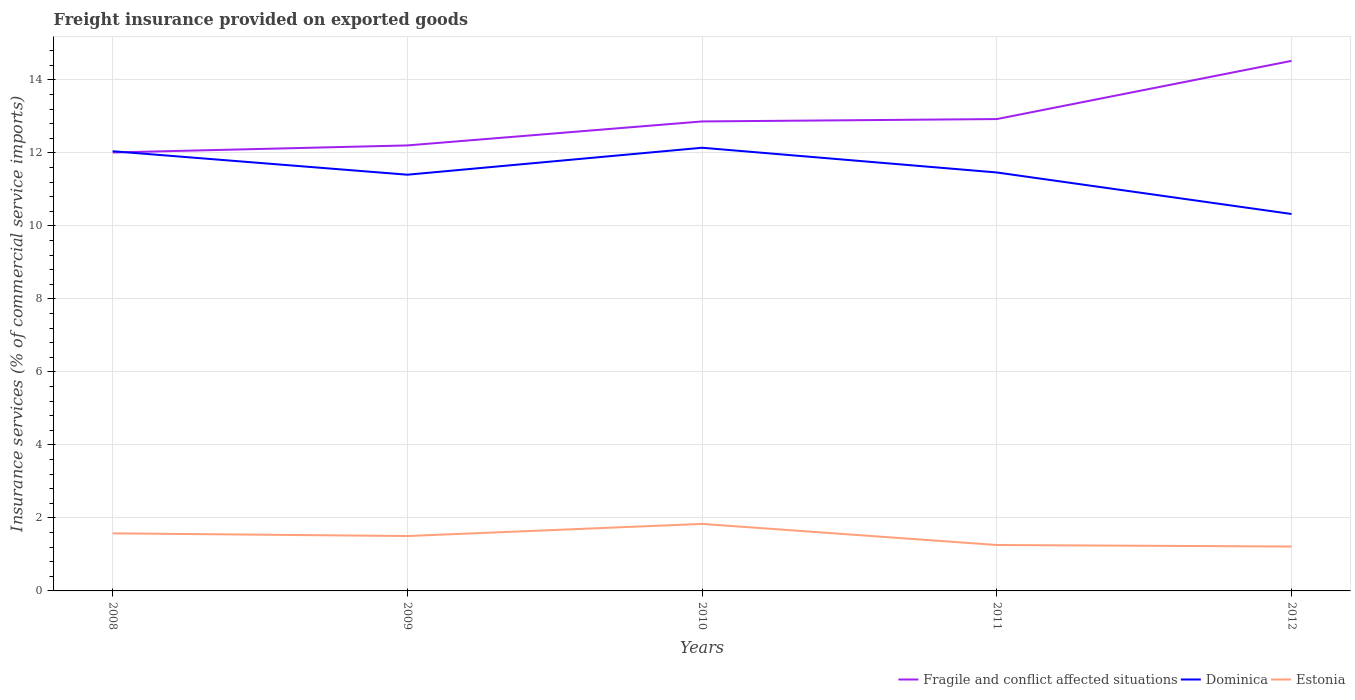Across all years, what is the maximum freight insurance provided on exported goods in Estonia?
Provide a short and direct response. 1.22. What is the total freight insurance provided on exported goods in Fragile and conflict affected situations in the graph?
Ensure brevity in your answer.  -2.32. What is the difference between the highest and the second highest freight insurance provided on exported goods in Fragile and conflict affected situations?
Offer a terse response. 2.51. Is the freight insurance provided on exported goods in Fragile and conflict affected situations strictly greater than the freight insurance provided on exported goods in Estonia over the years?
Your answer should be very brief. No. How many lines are there?
Offer a terse response. 3. What is the difference between two consecutive major ticks on the Y-axis?
Make the answer very short. 2. Are the values on the major ticks of Y-axis written in scientific E-notation?
Your response must be concise. No. Where does the legend appear in the graph?
Ensure brevity in your answer.  Bottom right. How many legend labels are there?
Provide a succinct answer. 3. What is the title of the graph?
Keep it short and to the point. Freight insurance provided on exported goods. Does "Sao Tome and Principe" appear as one of the legend labels in the graph?
Provide a succinct answer. No. What is the label or title of the X-axis?
Give a very brief answer. Years. What is the label or title of the Y-axis?
Your response must be concise. Insurance services (% of commercial service imports). What is the Insurance services (% of commercial service imports) in Fragile and conflict affected situations in 2008?
Provide a short and direct response. 12.01. What is the Insurance services (% of commercial service imports) in Dominica in 2008?
Your answer should be very brief. 12.05. What is the Insurance services (% of commercial service imports) of Estonia in 2008?
Make the answer very short. 1.58. What is the Insurance services (% of commercial service imports) of Fragile and conflict affected situations in 2009?
Ensure brevity in your answer.  12.21. What is the Insurance services (% of commercial service imports) in Dominica in 2009?
Make the answer very short. 11.4. What is the Insurance services (% of commercial service imports) of Estonia in 2009?
Offer a very short reply. 1.5. What is the Insurance services (% of commercial service imports) in Fragile and conflict affected situations in 2010?
Provide a succinct answer. 12.86. What is the Insurance services (% of commercial service imports) of Dominica in 2010?
Your response must be concise. 12.14. What is the Insurance services (% of commercial service imports) in Estonia in 2010?
Your answer should be very brief. 1.84. What is the Insurance services (% of commercial service imports) of Fragile and conflict affected situations in 2011?
Your answer should be compact. 12.93. What is the Insurance services (% of commercial service imports) in Dominica in 2011?
Make the answer very short. 11.46. What is the Insurance services (% of commercial service imports) of Estonia in 2011?
Your response must be concise. 1.26. What is the Insurance services (% of commercial service imports) in Fragile and conflict affected situations in 2012?
Provide a succinct answer. 14.52. What is the Insurance services (% of commercial service imports) in Dominica in 2012?
Your answer should be compact. 10.33. What is the Insurance services (% of commercial service imports) of Estonia in 2012?
Keep it short and to the point. 1.22. Across all years, what is the maximum Insurance services (% of commercial service imports) of Fragile and conflict affected situations?
Your answer should be compact. 14.52. Across all years, what is the maximum Insurance services (% of commercial service imports) of Dominica?
Ensure brevity in your answer.  12.14. Across all years, what is the maximum Insurance services (% of commercial service imports) of Estonia?
Offer a terse response. 1.84. Across all years, what is the minimum Insurance services (% of commercial service imports) of Fragile and conflict affected situations?
Your answer should be compact. 12.01. Across all years, what is the minimum Insurance services (% of commercial service imports) of Dominica?
Ensure brevity in your answer.  10.33. Across all years, what is the minimum Insurance services (% of commercial service imports) in Estonia?
Offer a very short reply. 1.22. What is the total Insurance services (% of commercial service imports) of Fragile and conflict affected situations in the graph?
Provide a succinct answer. 64.53. What is the total Insurance services (% of commercial service imports) of Dominica in the graph?
Keep it short and to the point. 57.38. What is the total Insurance services (% of commercial service imports) in Estonia in the graph?
Offer a terse response. 7.39. What is the difference between the Insurance services (% of commercial service imports) in Fragile and conflict affected situations in 2008 and that in 2009?
Make the answer very short. -0.19. What is the difference between the Insurance services (% of commercial service imports) in Dominica in 2008 and that in 2009?
Your answer should be very brief. 0.64. What is the difference between the Insurance services (% of commercial service imports) in Estonia in 2008 and that in 2009?
Make the answer very short. 0.07. What is the difference between the Insurance services (% of commercial service imports) of Fragile and conflict affected situations in 2008 and that in 2010?
Give a very brief answer. -0.85. What is the difference between the Insurance services (% of commercial service imports) in Dominica in 2008 and that in 2010?
Your response must be concise. -0.1. What is the difference between the Insurance services (% of commercial service imports) of Estonia in 2008 and that in 2010?
Provide a succinct answer. -0.26. What is the difference between the Insurance services (% of commercial service imports) of Fragile and conflict affected situations in 2008 and that in 2011?
Keep it short and to the point. -0.92. What is the difference between the Insurance services (% of commercial service imports) in Dominica in 2008 and that in 2011?
Your response must be concise. 0.58. What is the difference between the Insurance services (% of commercial service imports) of Estonia in 2008 and that in 2011?
Offer a very short reply. 0.32. What is the difference between the Insurance services (% of commercial service imports) of Fragile and conflict affected situations in 2008 and that in 2012?
Provide a succinct answer. -2.51. What is the difference between the Insurance services (% of commercial service imports) in Dominica in 2008 and that in 2012?
Provide a succinct answer. 1.72. What is the difference between the Insurance services (% of commercial service imports) in Estonia in 2008 and that in 2012?
Provide a succinct answer. 0.36. What is the difference between the Insurance services (% of commercial service imports) of Fragile and conflict affected situations in 2009 and that in 2010?
Your answer should be compact. -0.66. What is the difference between the Insurance services (% of commercial service imports) in Dominica in 2009 and that in 2010?
Your answer should be very brief. -0.74. What is the difference between the Insurance services (% of commercial service imports) in Estonia in 2009 and that in 2010?
Give a very brief answer. -0.33. What is the difference between the Insurance services (% of commercial service imports) of Fragile and conflict affected situations in 2009 and that in 2011?
Your answer should be very brief. -0.72. What is the difference between the Insurance services (% of commercial service imports) in Dominica in 2009 and that in 2011?
Your answer should be very brief. -0.06. What is the difference between the Insurance services (% of commercial service imports) in Estonia in 2009 and that in 2011?
Make the answer very short. 0.25. What is the difference between the Insurance services (% of commercial service imports) of Fragile and conflict affected situations in 2009 and that in 2012?
Make the answer very short. -2.32. What is the difference between the Insurance services (% of commercial service imports) of Dominica in 2009 and that in 2012?
Your answer should be compact. 1.08. What is the difference between the Insurance services (% of commercial service imports) in Estonia in 2009 and that in 2012?
Give a very brief answer. 0.29. What is the difference between the Insurance services (% of commercial service imports) of Fragile and conflict affected situations in 2010 and that in 2011?
Ensure brevity in your answer.  -0.06. What is the difference between the Insurance services (% of commercial service imports) in Dominica in 2010 and that in 2011?
Offer a terse response. 0.68. What is the difference between the Insurance services (% of commercial service imports) in Estonia in 2010 and that in 2011?
Your response must be concise. 0.58. What is the difference between the Insurance services (% of commercial service imports) of Fragile and conflict affected situations in 2010 and that in 2012?
Make the answer very short. -1.66. What is the difference between the Insurance services (% of commercial service imports) of Dominica in 2010 and that in 2012?
Make the answer very short. 1.82. What is the difference between the Insurance services (% of commercial service imports) of Estonia in 2010 and that in 2012?
Make the answer very short. 0.62. What is the difference between the Insurance services (% of commercial service imports) of Fragile and conflict affected situations in 2011 and that in 2012?
Make the answer very short. -1.59. What is the difference between the Insurance services (% of commercial service imports) of Dominica in 2011 and that in 2012?
Offer a terse response. 1.14. What is the difference between the Insurance services (% of commercial service imports) of Estonia in 2011 and that in 2012?
Keep it short and to the point. 0.04. What is the difference between the Insurance services (% of commercial service imports) in Fragile and conflict affected situations in 2008 and the Insurance services (% of commercial service imports) in Dominica in 2009?
Your answer should be compact. 0.61. What is the difference between the Insurance services (% of commercial service imports) of Fragile and conflict affected situations in 2008 and the Insurance services (% of commercial service imports) of Estonia in 2009?
Provide a short and direct response. 10.51. What is the difference between the Insurance services (% of commercial service imports) in Dominica in 2008 and the Insurance services (% of commercial service imports) in Estonia in 2009?
Provide a succinct answer. 10.54. What is the difference between the Insurance services (% of commercial service imports) in Fragile and conflict affected situations in 2008 and the Insurance services (% of commercial service imports) in Dominica in 2010?
Provide a short and direct response. -0.13. What is the difference between the Insurance services (% of commercial service imports) in Fragile and conflict affected situations in 2008 and the Insurance services (% of commercial service imports) in Estonia in 2010?
Your response must be concise. 10.18. What is the difference between the Insurance services (% of commercial service imports) in Dominica in 2008 and the Insurance services (% of commercial service imports) in Estonia in 2010?
Your answer should be very brief. 10.21. What is the difference between the Insurance services (% of commercial service imports) in Fragile and conflict affected situations in 2008 and the Insurance services (% of commercial service imports) in Dominica in 2011?
Your answer should be very brief. 0.55. What is the difference between the Insurance services (% of commercial service imports) in Fragile and conflict affected situations in 2008 and the Insurance services (% of commercial service imports) in Estonia in 2011?
Your answer should be compact. 10.75. What is the difference between the Insurance services (% of commercial service imports) of Dominica in 2008 and the Insurance services (% of commercial service imports) of Estonia in 2011?
Give a very brief answer. 10.79. What is the difference between the Insurance services (% of commercial service imports) in Fragile and conflict affected situations in 2008 and the Insurance services (% of commercial service imports) in Dominica in 2012?
Your response must be concise. 1.69. What is the difference between the Insurance services (% of commercial service imports) of Fragile and conflict affected situations in 2008 and the Insurance services (% of commercial service imports) of Estonia in 2012?
Ensure brevity in your answer.  10.8. What is the difference between the Insurance services (% of commercial service imports) of Dominica in 2008 and the Insurance services (% of commercial service imports) of Estonia in 2012?
Offer a very short reply. 10.83. What is the difference between the Insurance services (% of commercial service imports) of Fragile and conflict affected situations in 2009 and the Insurance services (% of commercial service imports) of Dominica in 2010?
Your response must be concise. 0.06. What is the difference between the Insurance services (% of commercial service imports) of Fragile and conflict affected situations in 2009 and the Insurance services (% of commercial service imports) of Estonia in 2010?
Offer a terse response. 10.37. What is the difference between the Insurance services (% of commercial service imports) of Dominica in 2009 and the Insurance services (% of commercial service imports) of Estonia in 2010?
Give a very brief answer. 9.57. What is the difference between the Insurance services (% of commercial service imports) in Fragile and conflict affected situations in 2009 and the Insurance services (% of commercial service imports) in Dominica in 2011?
Offer a very short reply. 0.74. What is the difference between the Insurance services (% of commercial service imports) of Fragile and conflict affected situations in 2009 and the Insurance services (% of commercial service imports) of Estonia in 2011?
Offer a very short reply. 10.95. What is the difference between the Insurance services (% of commercial service imports) of Dominica in 2009 and the Insurance services (% of commercial service imports) of Estonia in 2011?
Your answer should be very brief. 10.15. What is the difference between the Insurance services (% of commercial service imports) of Fragile and conflict affected situations in 2009 and the Insurance services (% of commercial service imports) of Dominica in 2012?
Your answer should be compact. 1.88. What is the difference between the Insurance services (% of commercial service imports) in Fragile and conflict affected situations in 2009 and the Insurance services (% of commercial service imports) in Estonia in 2012?
Offer a very short reply. 10.99. What is the difference between the Insurance services (% of commercial service imports) in Dominica in 2009 and the Insurance services (% of commercial service imports) in Estonia in 2012?
Offer a very short reply. 10.19. What is the difference between the Insurance services (% of commercial service imports) in Fragile and conflict affected situations in 2010 and the Insurance services (% of commercial service imports) in Dominica in 2011?
Your answer should be compact. 1.4. What is the difference between the Insurance services (% of commercial service imports) in Fragile and conflict affected situations in 2010 and the Insurance services (% of commercial service imports) in Estonia in 2011?
Give a very brief answer. 11.6. What is the difference between the Insurance services (% of commercial service imports) of Dominica in 2010 and the Insurance services (% of commercial service imports) of Estonia in 2011?
Your response must be concise. 10.88. What is the difference between the Insurance services (% of commercial service imports) of Fragile and conflict affected situations in 2010 and the Insurance services (% of commercial service imports) of Dominica in 2012?
Your response must be concise. 2.54. What is the difference between the Insurance services (% of commercial service imports) of Fragile and conflict affected situations in 2010 and the Insurance services (% of commercial service imports) of Estonia in 2012?
Your answer should be very brief. 11.65. What is the difference between the Insurance services (% of commercial service imports) in Dominica in 2010 and the Insurance services (% of commercial service imports) in Estonia in 2012?
Your response must be concise. 10.93. What is the difference between the Insurance services (% of commercial service imports) in Fragile and conflict affected situations in 2011 and the Insurance services (% of commercial service imports) in Dominica in 2012?
Offer a very short reply. 2.6. What is the difference between the Insurance services (% of commercial service imports) in Fragile and conflict affected situations in 2011 and the Insurance services (% of commercial service imports) in Estonia in 2012?
Offer a very short reply. 11.71. What is the difference between the Insurance services (% of commercial service imports) in Dominica in 2011 and the Insurance services (% of commercial service imports) in Estonia in 2012?
Keep it short and to the point. 10.25. What is the average Insurance services (% of commercial service imports) of Fragile and conflict affected situations per year?
Make the answer very short. 12.91. What is the average Insurance services (% of commercial service imports) of Dominica per year?
Give a very brief answer. 11.48. What is the average Insurance services (% of commercial service imports) in Estonia per year?
Offer a terse response. 1.48. In the year 2008, what is the difference between the Insurance services (% of commercial service imports) of Fragile and conflict affected situations and Insurance services (% of commercial service imports) of Dominica?
Provide a short and direct response. -0.03. In the year 2008, what is the difference between the Insurance services (% of commercial service imports) of Fragile and conflict affected situations and Insurance services (% of commercial service imports) of Estonia?
Ensure brevity in your answer.  10.43. In the year 2008, what is the difference between the Insurance services (% of commercial service imports) of Dominica and Insurance services (% of commercial service imports) of Estonia?
Make the answer very short. 10.47. In the year 2009, what is the difference between the Insurance services (% of commercial service imports) of Fragile and conflict affected situations and Insurance services (% of commercial service imports) of Dominica?
Make the answer very short. 0.8. In the year 2009, what is the difference between the Insurance services (% of commercial service imports) in Fragile and conflict affected situations and Insurance services (% of commercial service imports) in Estonia?
Provide a succinct answer. 10.7. In the year 2009, what is the difference between the Insurance services (% of commercial service imports) in Dominica and Insurance services (% of commercial service imports) in Estonia?
Ensure brevity in your answer.  9.9. In the year 2010, what is the difference between the Insurance services (% of commercial service imports) of Fragile and conflict affected situations and Insurance services (% of commercial service imports) of Dominica?
Offer a terse response. 0.72. In the year 2010, what is the difference between the Insurance services (% of commercial service imports) in Fragile and conflict affected situations and Insurance services (% of commercial service imports) in Estonia?
Your answer should be compact. 11.03. In the year 2010, what is the difference between the Insurance services (% of commercial service imports) of Dominica and Insurance services (% of commercial service imports) of Estonia?
Your answer should be compact. 10.31. In the year 2011, what is the difference between the Insurance services (% of commercial service imports) of Fragile and conflict affected situations and Insurance services (% of commercial service imports) of Dominica?
Your answer should be very brief. 1.46. In the year 2011, what is the difference between the Insurance services (% of commercial service imports) of Fragile and conflict affected situations and Insurance services (% of commercial service imports) of Estonia?
Keep it short and to the point. 11.67. In the year 2011, what is the difference between the Insurance services (% of commercial service imports) in Dominica and Insurance services (% of commercial service imports) in Estonia?
Make the answer very short. 10.21. In the year 2012, what is the difference between the Insurance services (% of commercial service imports) of Fragile and conflict affected situations and Insurance services (% of commercial service imports) of Dominica?
Ensure brevity in your answer.  4.2. In the year 2012, what is the difference between the Insurance services (% of commercial service imports) of Fragile and conflict affected situations and Insurance services (% of commercial service imports) of Estonia?
Your answer should be compact. 13.31. In the year 2012, what is the difference between the Insurance services (% of commercial service imports) of Dominica and Insurance services (% of commercial service imports) of Estonia?
Ensure brevity in your answer.  9.11. What is the ratio of the Insurance services (% of commercial service imports) of Fragile and conflict affected situations in 2008 to that in 2009?
Offer a terse response. 0.98. What is the ratio of the Insurance services (% of commercial service imports) of Dominica in 2008 to that in 2009?
Make the answer very short. 1.06. What is the ratio of the Insurance services (% of commercial service imports) of Estonia in 2008 to that in 2009?
Provide a succinct answer. 1.05. What is the ratio of the Insurance services (% of commercial service imports) of Fragile and conflict affected situations in 2008 to that in 2010?
Your answer should be compact. 0.93. What is the ratio of the Insurance services (% of commercial service imports) of Estonia in 2008 to that in 2010?
Ensure brevity in your answer.  0.86. What is the ratio of the Insurance services (% of commercial service imports) in Fragile and conflict affected situations in 2008 to that in 2011?
Provide a short and direct response. 0.93. What is the ratio of the Insurance services (% of commercial service imports) in Dominica in 2008 to that in 2011?
Your response must be concise. 1.05. What is the ratio of the Insurance services (% of commercial service imports) of Estonia in 2008 to that in 2011?
Ensure brevity in your answer.  1.25. What is the ratio of the Insurance services (% of commercial service imports) of Fragile and conflict affected situations in 2008 to that in 2012?
Make the answer very short. 0.83. What is the ratio of the Insurance services (% of commercial service imports) of Dominica in 2008 to that in 2012?
Give a very brief answer. 1.17. What is the ratio of the Insurance services (% of commercial service imports) of Estonia in 2008 to that in 2012?
Offer a terse response. 1.3. What is the ratio of the Insurance services (% of commercial service imports) of Fragile and conflict affected situations in 2009 to that in 2010?
Your answer should be very brief. 0.95. What is the ratio of the Insurance services (% of commercial service imports) in Dominica in 2009 to that in 2010?
Ensure brevity in your answer.  0.94. What is the ratio of the Insurance services (% of commercial service imports) in Estonia in 2009 to that in 2010?
Provide a short and direct response. 0.82. What is the ratio of the Insurance services (% of commercial service imports) of Fragile and conflict affected situations in 2009 to that in 2011?
Offer a terse response. 0.94. What is the ratio of the Insurance services (% of commercial service imports) of Dominica in 2009 to that in 2011?
Give a very brief answer. 0.99. What is the ratio of the Insurance services (% of commercial service imports) of Estonia in 2009 to that in 2011?
Your answer should be very brief. 1.2. What is the ratio of the Insurance services (% of commercial service imports) of Fragile and conflict affected situations in 2009 to that in 2012?
Make the answer very short. 0.84. What is the ratio of the Insurance services (% of commercial service imports) in Dominica in 2009 to that in 2012?
Provide a short and direct response. 1.1. What is the ratio of the Insurance services (% of commercial service imports) in Estonia in 2009 to that in 2012?
Offer a very short reply. 1.24. What is the ratio of the Insurance services (% of commercial service imports) in Fragile and conflict affected situations in 2010 to that in 2011?
Your answer should be compact. 0.99. What is the ratio of the Insurance services (% of commercial service imports) in Dominica in 2010 to that in 2011?
Your answer should be very brief. 1.06. What is the ratio of the Insurance services (% of commercial service imports) of Estonia in 2010 to that in 2011?
Make the answer very short. 1.46. What is the ratio of the Insurance services (% of commercial service imports) in Fragile and conflict affected situations in 2010 to that in 2012?
Offer a very short reply. 0.89. What is the ratio of the Insurance services (% of commercial service imports) in Dominica in 2010 to that in 2012?
Your response must be concise. 1.18. What is the ratio of the Insurance services (% of commercial service imports) in Estonia in 2010 to that in 2012?
Provide a succinct answer. 1.51. What is the ratio of the Insurance services (% of commercial service imports) of Fragile and conflict affected situations in 2011 to that in 2012?
Offer a very short reply. 0.89. What is the ratio of the Insurance services (% of commercial service imports) in Dominica in 2011 to that in 2012?
Make the answer very short. 1.11. What is the ratio of the Insurance services (% of commercial service imports) of Estonia in 2011 to that in 2012?
Offer a very short reply. 1.03. What is the difference between the highest and the second highest Insurance services (% of commercial service imports) in Fragile and conflict affected situations?
Your answer should be compact. 1.59. What is the difference between the highest and the second highest Insurance services (% of commercial service imports) of Dominica?
Offer a very short reply. 0.1. What is the difference between the highest and the second highest Insurance services (% of commercial service imports) of Estonia?
Your response must be concise. 0.26. What is the difference between the highest and the lowest Insurance services (% of commercial service imports) of Fragile and conflict affected situations?
Ensure brevity in your answer.  2.51. What is the difference between the highest and the lowest Insurance services (% of commercial service imports) in Dominica?
Keep it short and to the point. 1.82. What is the difference between the highest and the lowest Insurance services (% of commercial service imports) of Estonia?
Ensure brevity in your answer.  0.62. 